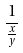<formula> <loc_0><loc_0><loc_500><loc_500>\frac { 1 } { \frac { x } { y } }</formula> 